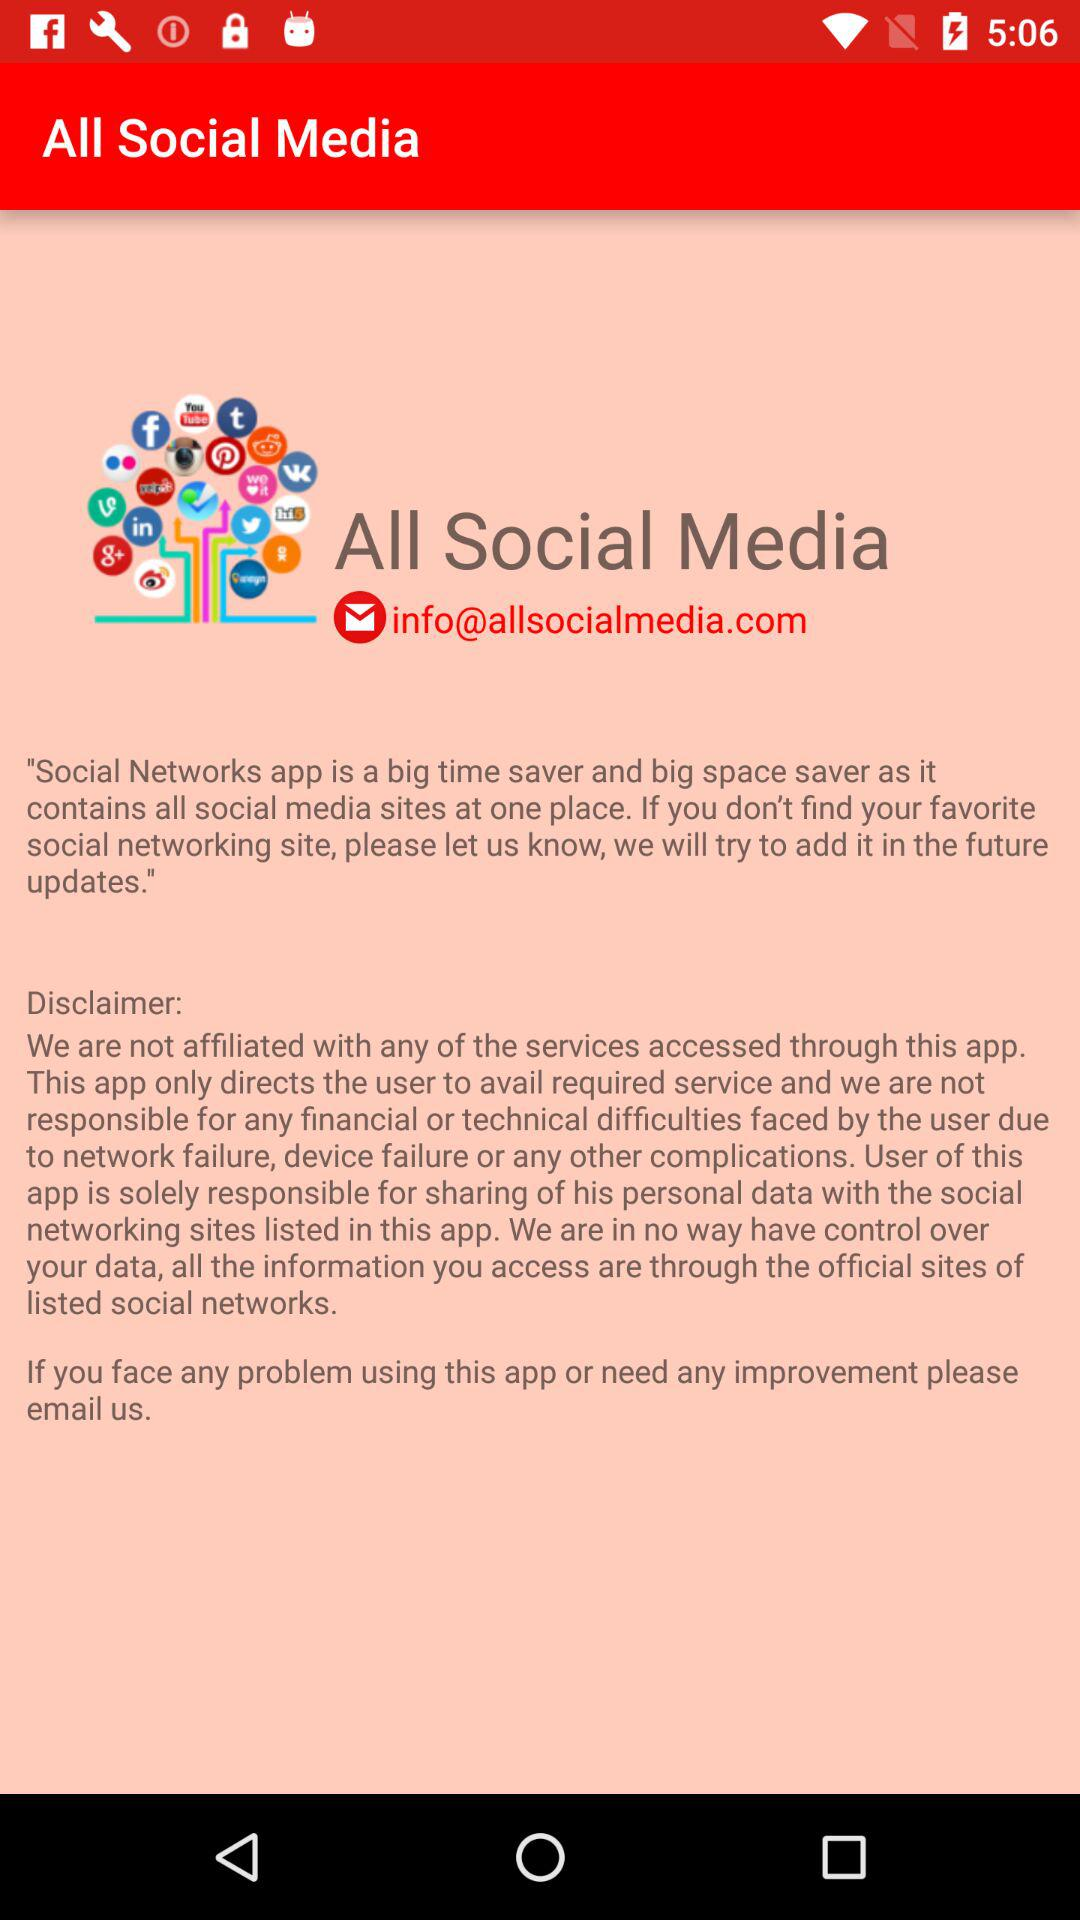What is the given email address? The given email address is info@allsocialmedia.com. 